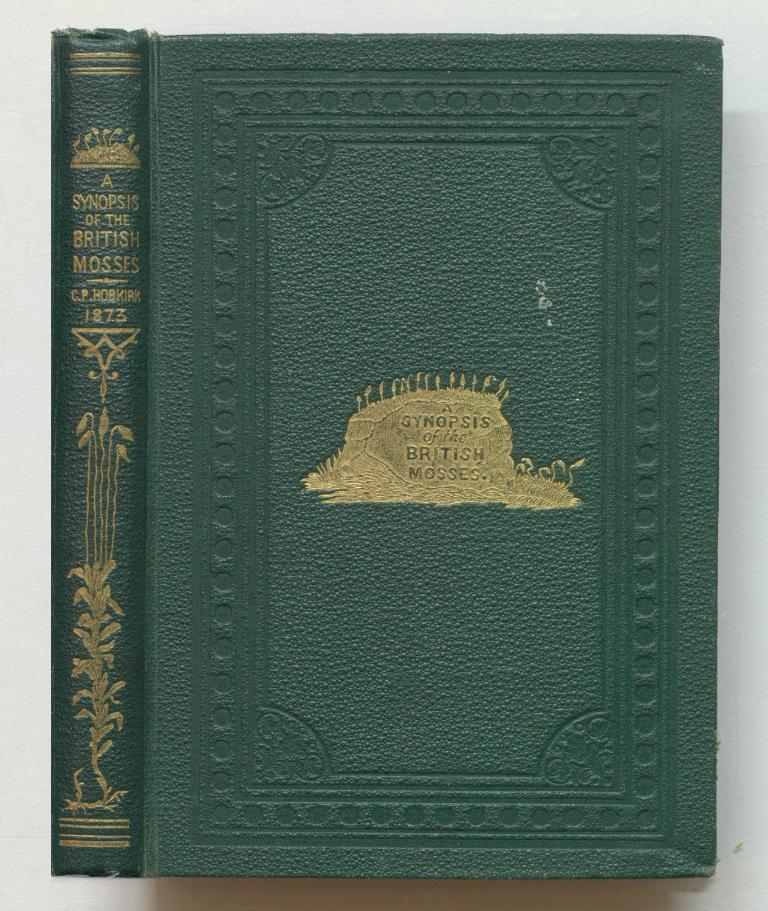Provide a one-sentence caption for the provided image. A Synopsis of the British Mosses sits open on a white table, with green leather binding. 